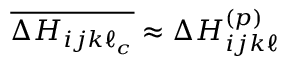<formula> <loc_0><loc_0><loc_500><loc_500>\overline { { \Delta H _ { i j k \ell _ { c } } } } \approx \Delta H _ { i j k \ell } ^ { ( p ) }</formula> 